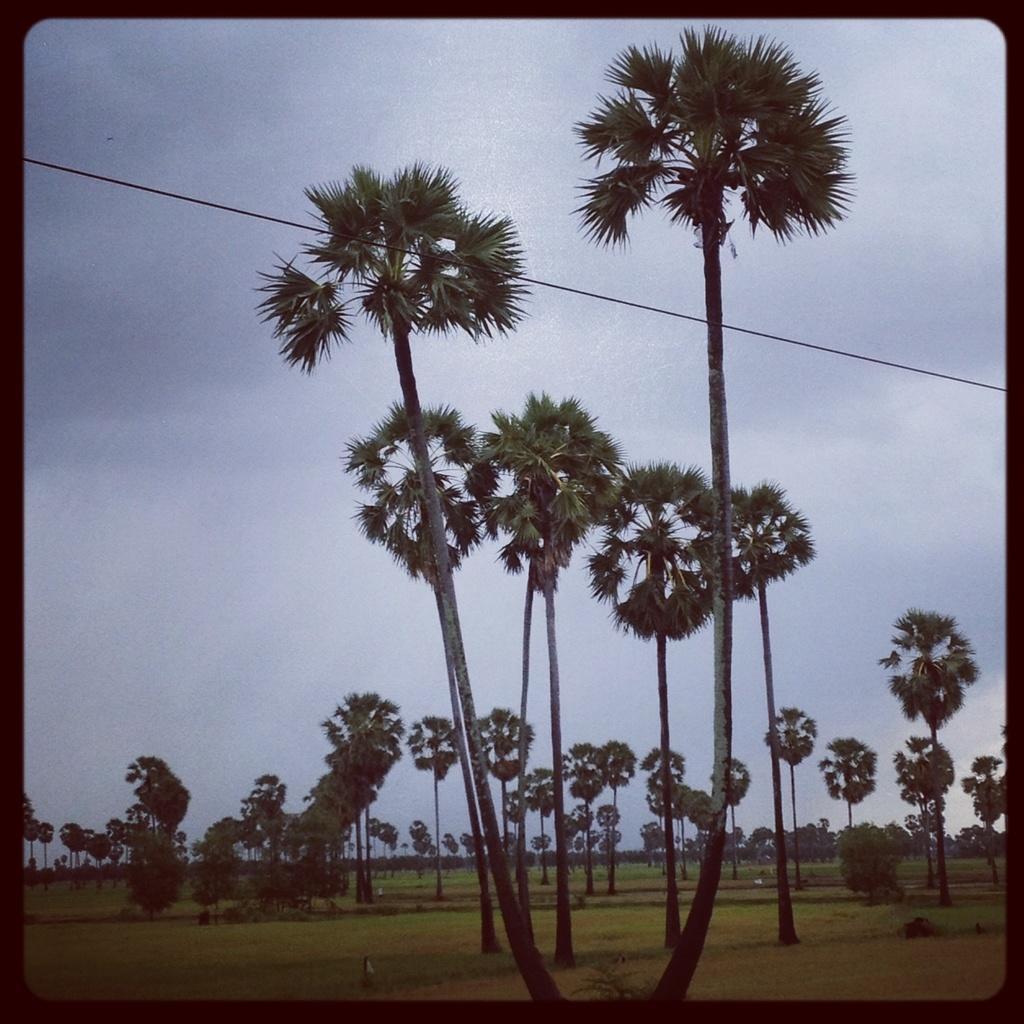How would you summarize this image in a sentence or two? In this image we can see trees. At the bottom of the image there is grass. In the background of the image there is sky and clouds. 